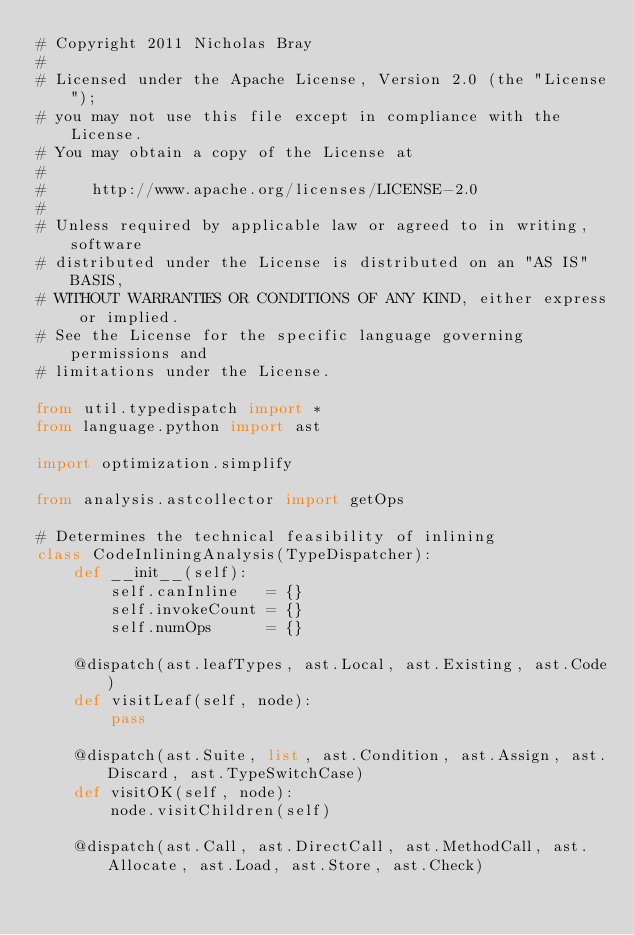<code> <loc_0><loc_0><loc_500><loc_500><_Python_># Copyright 2011 Nicholas Bray
#
# Licensed under the Apache License, Version 2.0 (the "License");
# you may not use this file except in compliance with the License.
# You may obtain a copy of the License at
#
#     http://www.apache.org/licenses/LICENSE-2.0
#
# Unless required by applicable law or agreed to in writing, software
# distributed under the License is distributed on an "AS IS" BASIS,
# WITHOUT WARRANTIES OR CONDITIONS OF ANY KIND, either express or implied.
# See the License for the specific language governing permissions and
# limitations under the License.

from util.typedispatch import *
from language.python import ast

import optimization.simplify

from analysis.astcollector import getOps

# Determines the technical feasibility of inlining
class CodeInliningAnalysis(TypeDispatcher):
	def __init__(self):
		self.canInline   = {}
		self.invokeCount = {}
		self.numOps      = {}

	@dispatch(ast.leafTypes, ast.Local, ast.Existing, ast.Code)
	def visitLeaf(self, node):
		pass

	@dispatch(ast.Suite, list, ast.Condition, ast.Assign, ast.Discard, ast.TypeSwitchCase)
	def visitOK(self, node):
		node.visitChildren(self)

	@dispatch(ast.Call, ast.DirectCall, ast.MethodCall, ast.Allocate, ast.Load, ast.Store, ast.Check)</code> 